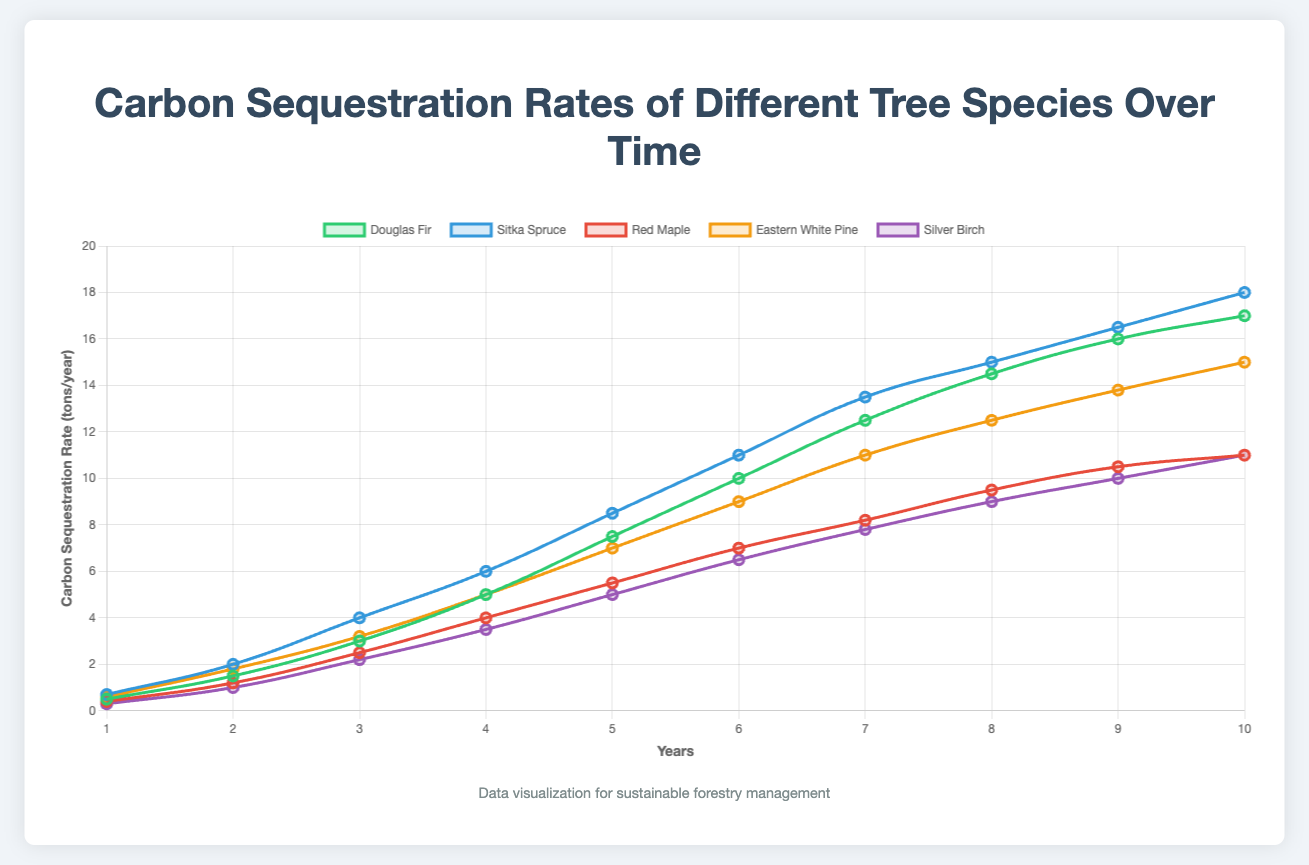Which tree species has the highest carbon sequestration rate in the 10th year? By examining the figure, it's clear that Sitka Spruce has the highest sequestration rate in the 10th year.
Answer: Sitka Spruce Which tree species shows the fastest increase in carbon sequestration rate in the first 4 years? From the visual trend, Sitka Spruce shows the steepest slope in the first 4 years, indicating the fastest increase.
Answer: Sitka Spruce What is the difference in carbon sequestration rates between Sitka Spruce and Red Maple at year 5? At year 5, Sitka Spruce has a rate of 8.5 tons/year and Red Maple has 5.5 tons/year. The difference is 8.5 - 5.5.
Answer: 3 tons/year How does the carbon sequestration rate of Silver Birch at year 7 compare to that of Douglas Fir in the same year? At year 7, Silver Birch sequesters 7.8 tons/year while Douglas Fir sequesters 12.5 tons/year. Douglas Fir has a higher rate.
Answer: Douglas Fir has a higher rate What is the average carbon sequestration rate of Eastern White Pine over the 10 years? Summing the values (0.6+1.8+3.2+5.0+7.0+9.0+11.0+12.5+13.8+15.0) gives 78.9. Dividing by 10 gives an average of 7.89 tons/year.
Answer: 7.89 tons/year Which tree species has the lowest carbon sequestration rate in the 1st year, and what is that value? From the figure, Silver Birch has the lowest rate in the 1st year, which is 0.3 tons/year.
Answer: Silver Birch, 0.3 tons/year What's the total carbon sequestration rate of all tree species combined at year 9? Adding rates at year 9 for each species: Douglas Fir (16) + Sitka Spruce (16.5) + Red Maple (10.5) + Eastern White Pine (13.8) + Silver Birch (10) yields a total of 66.8 tons/year.
Answer: 66.8 tons/year How does the visual representation of Silver Birch's carbon sequestration rate compare to the other species in terms of slope steepness? Silver Birch shows a more gradual incline, indicating a slower sequestration rate increase compared to other species like Sitka Spruce and Douglas Fir which have steeper lines.
Answer: Gradual incline Which species shows a similar carbon sequestration rate trend to Sitka Spruce but slightly lagging in terms of sequestration amount? Eastern White Pine follows a similar rising trend as Sitka Spruce but at slightly lower rates.
Answer: Eastern White Pine 